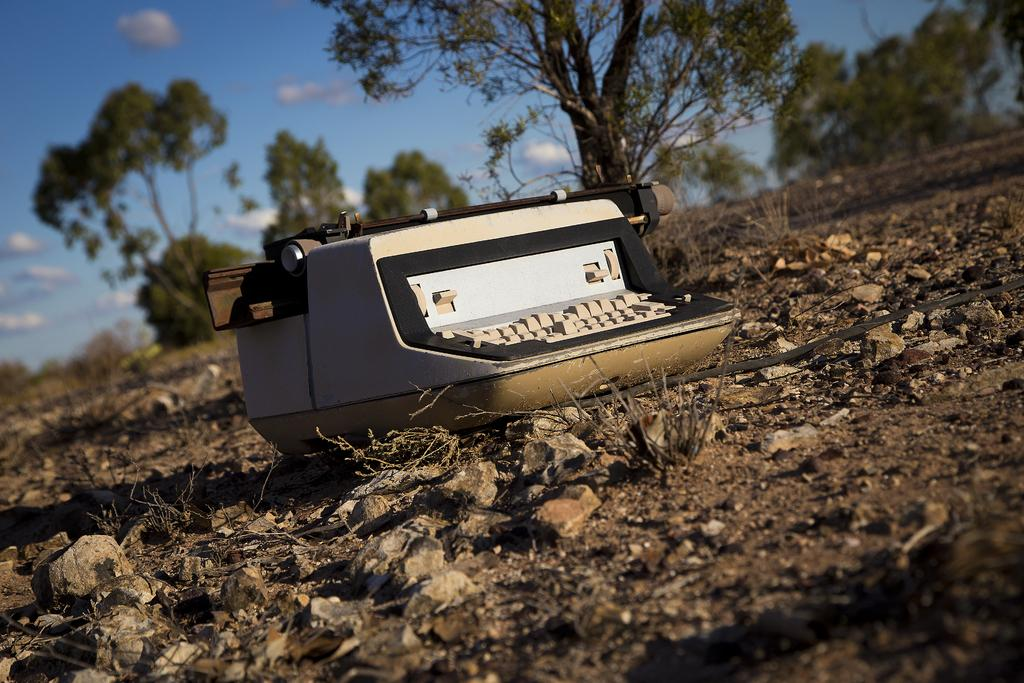What is the main object in the image? There is a typing machine in the image. What can be seen at the bottom of the image? There are stones at the bottom of the image. What type of natural elements are visible in the background of the image? There are trees in the background of the image. What is visible at the top of the image? The sky is visible at the top of the image. What type of coal is being used to fuel the typing machine in the image? There is no coal present in the image, and the typing machine does not require fuel to operate. 